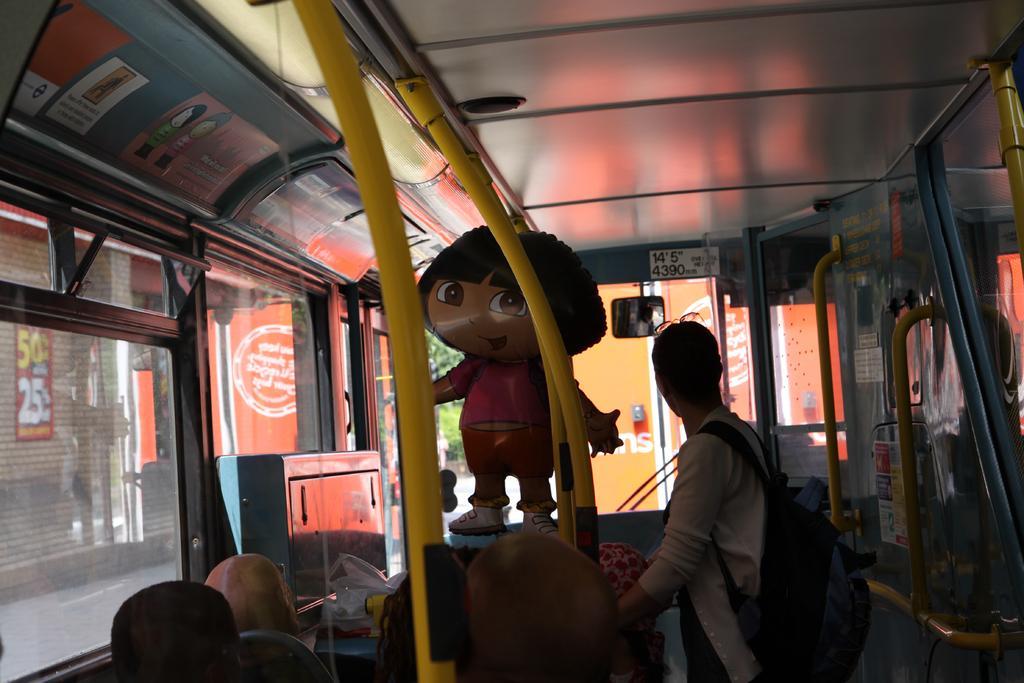Can you describe this image briefly? This is a picture of inside of a vehicle, in this image there are some persons sitting and one person is standing and there is one toy, poles and glass windows. And through the windows i can see some shutters, and some boards. 